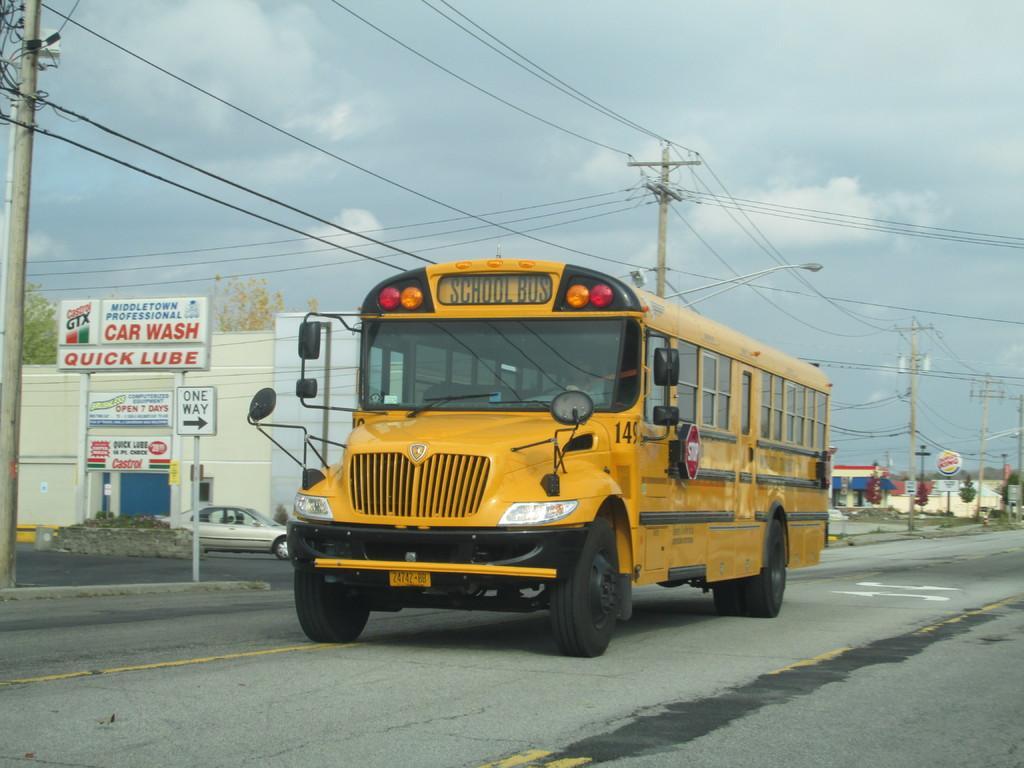Describe this image in one or two sentences. In the picture I can see a yellow color school bus is moving on the road, here I can see light poles, current poles, wires, boards, houses, trees and the cloudy sky in the background. 